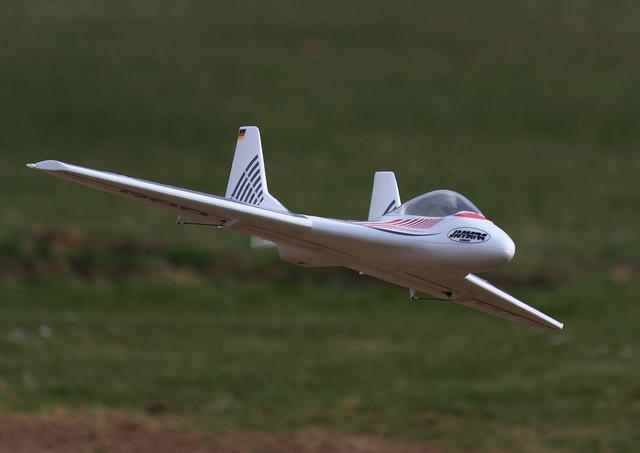How many people in the plane?
Give a very brief answer. 0. 